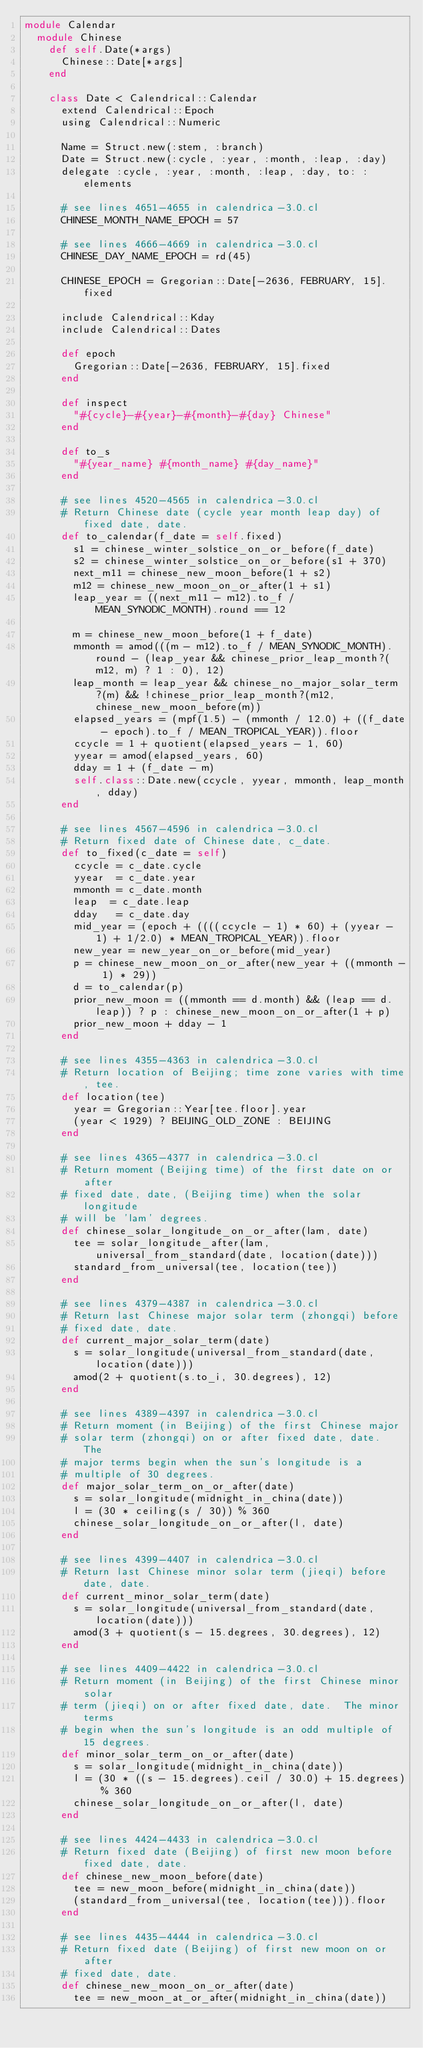<code> <loc_0><loc_0><loc_500><loc_500><_Ruby_>module Calendar
  module Chinese
    def self.Date(*args)
      Chinese::Date[*args]
    end
    
    class Date < Calendrical::Calendar
      extend Calendrical::Epoch
      using Calendrical::Numeric
    
      Name = Struct.new(:stem, :branch)
      Date = Struct.new(:cycle, :year, :month, :leap, :day)
      delegate :cycle, :year, :month, :leap, :day, to: :elements
  
      # see lines 4651-4655 in calendrica-3.0.cl
      CHINESE_MONTH_NAME_EPOCH = 57
  
      # see lines 4666-4669 in calendrica-3.0.cl
      CHINESE_DAY_NAME_EPOCH = rd(45)
    
      CHINESE_EPOCH = Gregorian::Date[-2636, FEBRUARY, 15].fixed

      include Calendrical::Kday
      include Calendrical::Dates
  
      def epoch
        Gregorian::Date[-2636, FEBRUARY, 15].fixed
      end
  
      def inspect
        "#{cycle}-#{year}-#{month}-#{day} Chinese"
      end

      def to_s
        "#{year_name} #{month_name} #{day_name}"
      end

      # see lines 4520-4565 in calendrica-3.0.cl
      # Return Chinese date (cycle year month leap day) of fixed date, date.
      def to_calendar(f_date = self.fixed)
        s1 = chinese_winter_solstice_on_or_before(f_date)
        s2 = chinese_winter_solstice_on_or_before(s1 + 370)
        next_m11 = chinese_new_moon_before(1 + s2)
        m12 = chinese_new_moon_on_or_after(1 + s1)
        leap_year = ((next_m11 - m12).to_f / MEAN_SYNODIC_MONTH).round == 12

        m = chinese_new_moon_before(1 + f_date)
        mmonth = amod(((m - m12).to_f / MEAN_SYNODIC_MONTH).round - (leap_year && chinese_prior_leap_month?(m12, m) ? 1 : 0), 12)
        leap_month = leap_year && chinese_no_major_solar_term?(m) && !chinese_prior_leap_month?(m12, chinese_new_moon_before(m))
        elapsed_years = (mpf(1.5) - (mmonth / 12.0) + ((f_date - epoch).to_f / MEAN_TROPICAL_YEAR)).floor
        ccycle = 1 + quotient(elapsed_years - 1, 60)
        yyear = amod(elapsed_years, 60)
        dday = 1 + (f_date - m)
        self.class::Date.new(ccycle, yyear, mmonth, leap_month, dday)
      end

      # see lines 4567-4596 in calendrica-3.0.cl
      # Return fixed date of Chinese date, c_date.
      def to_fixed(c_date = self)
        ccycle = c_date.cycle
        yyear  = c_date.year
        mmonth = c_date.month
        leap  = c_date.leap
        dday   = c_date.day
        mid_year = (epoch + ((((ccycle - 1) * 60) + (yyear - 1) + 1/2.0) * MEAN_TROPICAL_YEAR)).floor
        new_year = new_year_on_or_before(mid_year)
        p = chinese_new_moon_on_or_after(new_year + ((mmonth - 1) * 29))
        d = to_calendar(p)
        prior_new_moon = ((mmonth == d.month) && (leap == d.leap)) ? p : chinese_new_moon_on_or_after(1 + p)
        prior_new_moon + dday - 1
      end
  
      # see lines 4355-4363 in calendrica-3.0.cl
      # Return location of Beijing; time zone varies with time, tee.
      def location(tee)
        year = Gregorian::Year[tee.floor].year
        (year < 1929) ? BEIJING_OLD_ZONE : BEIJING
      end

      # see lines 4365-4377 in calendrica-3.0.cl
      # Return moment (Beijing time) of the first date on or after
      # fixed date, date, (Beijing time) when the solar longitude
      # will be 'lam' degrees.
      def chinese_solar_longitude_on_or_after(lam, date)
        tee = solar_longitude_after(lam, universal_from_standard(date, location(date)))
        standard_from_universal(tee, location(tee))
      end

      # see lines 4379-4387 in calendrica-3.0.cl
      # Return last Chinese major solar term (zhongqi) before
      # fixed date, date.
      def current_major_solar_term(date)
        s = solar_longitude(universal_from_standard(date, location(date)))
        amod(2 + quotient(s.to_i, 30.degrees), 12)
      end

      # see lines 4389-4397 in calendrica-3.0.cl
      # Return moment (in Beijing) of the first Chinese major
      # solar term (zhongqi) on or after fixed date, date.  The
      # major terms begin when the sun's longitude is a
      # multiple of 30 degrees.
      def major_solar_term_on_or_after(date)
        s = solar_longitude(midnight_in_china(date))
        l = (30 * ceiling(s / 30)) % 360
        chinese_solar_longitude_on_or_after(l, date)
      end

      # see lines 4399-4407 in calendrica-3.0.cl
      # Return last Chinese minor solar term (jieqi) before date, date.
      def current_minor_solar_term(date)
        s = solar_longitude(universal_from_standard(date, location(date)))
        amod(3 + quotient(s - 15.degrees, 30.degrees), 12)
      end

      # see lines 4409-4422 in calendrica-3.0.cl
      # Return moment (in Beijing) of the first Chinese minor solar
      # term (jieqi) on or after fixed date, date.  The minor terms
      # begin when the sun's longitude is an odd multiple of 15 degrees.
      def minor_solar_term_on_or_after(date)
        s = solar_longitude(midnight_in_china(date))
        l = (30 * ((s - 15.degrees).ceil / 30.0) + 15.degrees) % 360
        chinese_solar_longitude_on_or_after(l, date)
      end

      # see lines 4424-4433 in calendrica-3.0.cl
      # Return fixed date (Beijing) of first new moon before fixed date, date.
      def chinese_new_moon_before(date)
        tee = new_moon_before(midnight_in_china(date))
        (standard_from_universal(tee, location(tee))).floor
      end

      # see lines 4435-4444 in calendrica-3.0.cl
      # Return fixed date (Beijing) of first new moon on or after
      # fixed date, date.
      def chinese_new_moon_on_or_after(date)
        tee = new_moon_at_or_after(midnight_in_china(date))</code> 